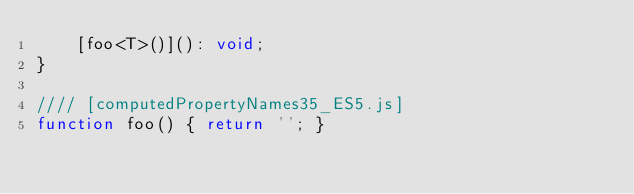<code> <loc_0><loc_0><loc_500><loc_500><_JavaScript_>    [foo<T>()](): void;
}

//// [computedPropertyNames35_ES5.js]
function foo() { return ''; }
</code> 